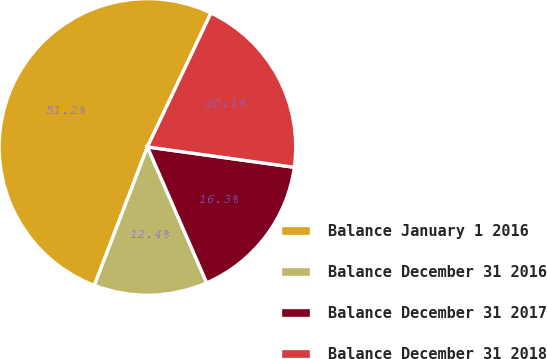Convert chart to OTSL. <chart><loc_0><loc_0><loc_500><loc_500><pie_chart><fcel>Balance January 1 2016<fcel>Balance December 31 2016<fcel>Balance December 31 2017<fcel>Balance December 31 2018<nl><fcel>51.22%<fcel>12.37%<fcel>16.26%<fcel>20.14%<nl></chart> 